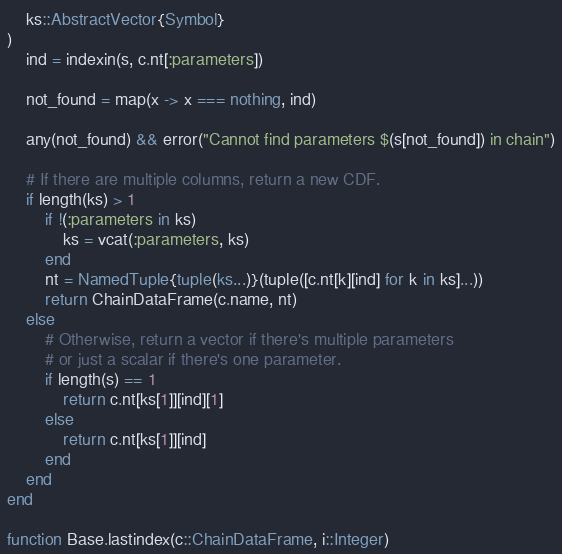<code> <loc_0><loc_0><loc_500><loc_500><_Julia_>    ks::AbstractVector{Symbol}
)
    ind = indexin(s, c.nt[:parameters])

    not_found = map(x -> x === nothing, ind)

    any(not_found) && error("Cannot find parameters $(s[not_found]) in chain")

    # If there are multiple columns, return a new CDF.
    if length(ks) > 1
        if !(:parameters in ks)
            ks = vcat(:parameters, ks)
        end
        nt = NamedTuple{tuple(ks...)}(tuple([c.nt[k][ind] for k in ks]...))
        return ChainDataFrame(c.name, nt)
    else
        # Otherwise, return a vector if there's multiple parameters
        # or just a scalar if there's one parameter.
        if length(s) == 1
            return c.nt[ks[1]][ind][1]
        else
            return c.nt[ks[1]][ind]
        end
    end
end

function Base.lastindex(c::ChainDataFrame, i::Integer)</code> 